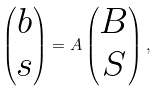Convert formula to latex. <formula><loc_0><loc_0><loc_500><loc_500>\begin{pmatrix} b \\ s \end{pmatrix} = A \begin{pmatrix} B \\ S \end{pmatrix} ,</formula> 